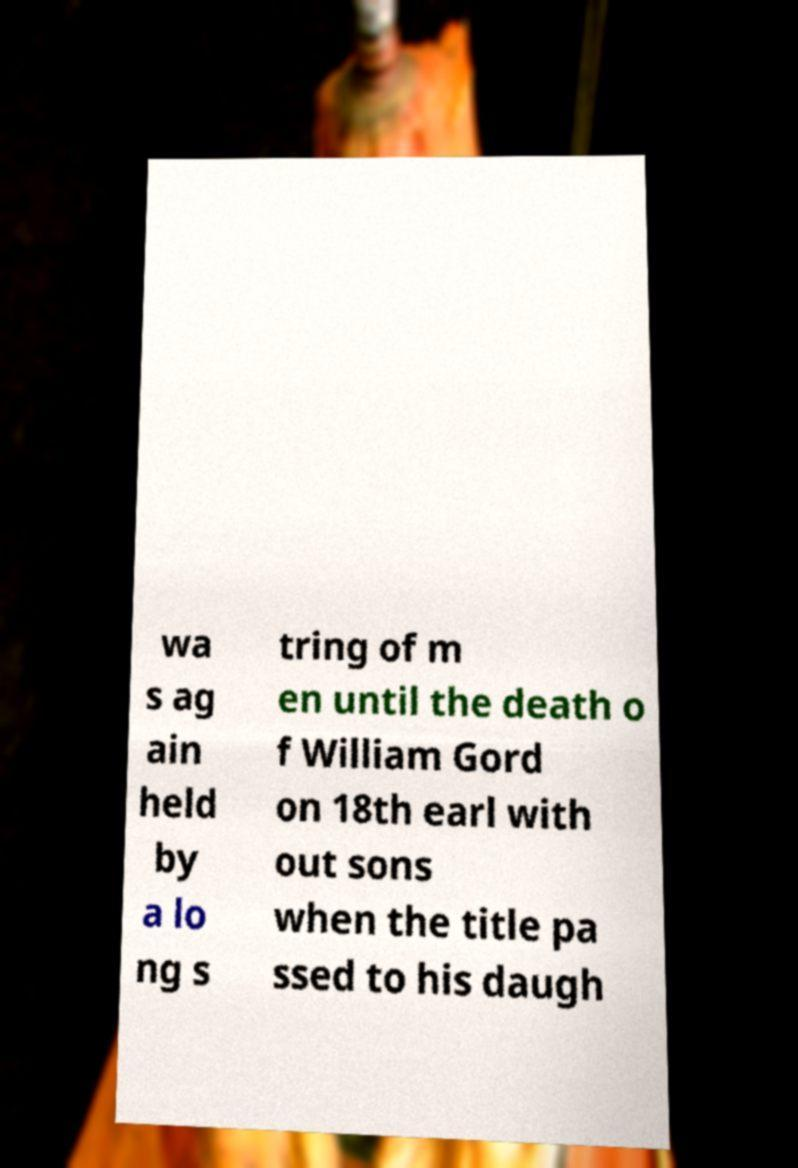What messages or text are displayed in this image? I need them in a readable, typed format. wa s ag ain held by a lo ng s tring of m en until the death o f William Gord on 18th earl with out sons when the title pa ssed to his daugh 